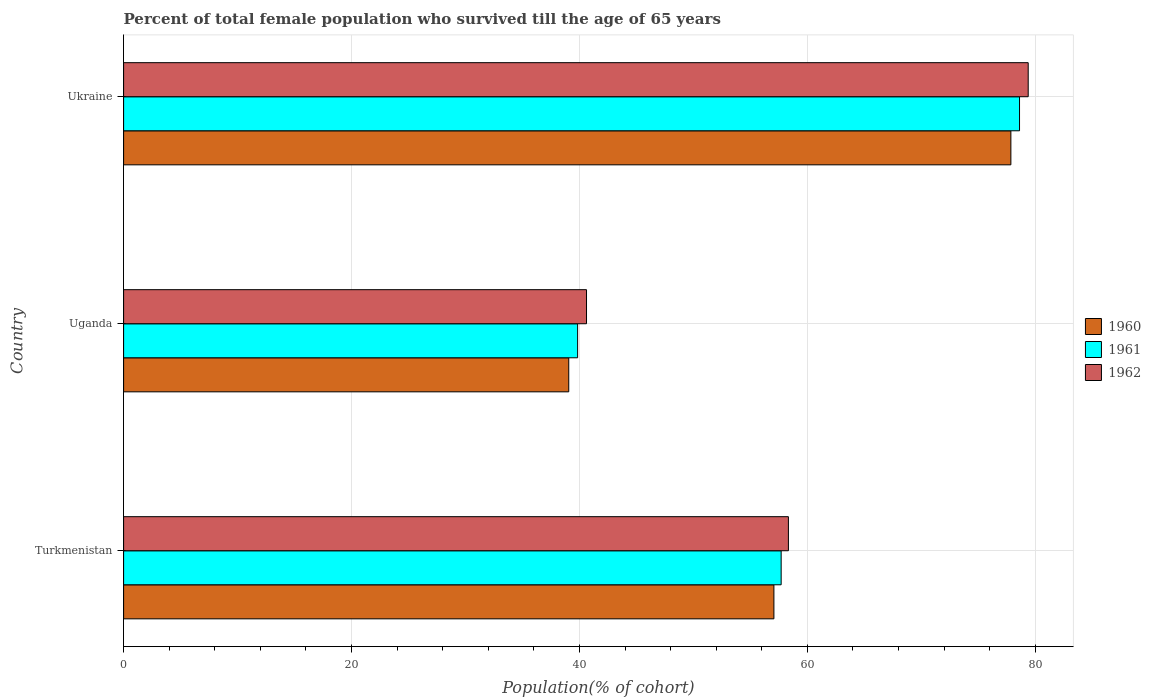How many different coloured bars are there?
Your answer should be compact. 3. What is the label of the 3rd group of bars from the top?
Ensure brevity in your answer.  Turkmenistan. In how many cases, is the number of bars for a given country not equal to the number of legend labels?
Provide a succinct answer. 0. What is the percentage of total female population who survived till the age of 65 years in 1962 in Turkmenistan?
Give a very brief answer. 58.33. Across all countries, what is the maximum percentage of total female population who survived till the age of 65 years in 1962?
Ensure brevity in your answer.  79.37. Across all countries, what is the minimum percentage of total female population who survived till the age of 65 years in 1962?
Keep it short and to the point. 40.62. In which country was the percentage of total female population who survived till the age of 65 years in 1960 maximum?
Your answer should be very brief. Ukraine. In which country was the percentage of total female population who survived till the age of 65 years in 1961 minimum?
Give a very brief answer. Uganda. What is the total percentage of total female population who survived till the age of 65 years in 1961 in the graph?
Provide a succinct answer. 176.15. What is the difference between the percentage of total female population who survived till the age of 65 years in 1962 in Turkmenistan and that in Uganda?
Offer a very short reply. 17.71. What is the difference between the percentage of total female population who survived till the age of 65 years in 1962 in Uganda and the percentage of total female population who survived till the age of 65 years in 1960 in Turkmenistan?
Your answer should be very brief. -16.44. What is the average percentage of total female population who survived till the age of 65 years in 1961 per country?
Your response must be concise. 58.72. What is the difference between the percentage of total female population who survived till the age of 65 years in 1961 and percentage of total female population who survived till the age of 65 years in 1962 in Ukraine?
Your answer should be compact. -0.76. What is the ratio of the percentage of total female population who survived till the age of 65 years in 1961 in Uganda to that in Ukraine?
Give a very brief answer. 0.51. What is the difference between the highest and the second highest percentage of total female population who survived till the age of 65 years in 1960?
Provide a short and direct response. 20.79. What is the difference between the highest and the lowest percentage of total female population who survived till the age of 65 years in 1960?
Provide a short and direct response. 38.79. In how many countries, is the percentage of total female population who survived till the age of 65 years in 1961 greater than the average percentage of total female population who survived till the age of 65 years in 1961 taken over all countries?
Offer a very short reply. 1. Is the sum of the percentage of total female population who survived till the age of 65 years in 1961 in Turkmenistan and Uganda greater than the maximum percentage of total female population who survived till the age of 65 years in 1962 across all countries?
Keep it short and to the point. Yes. What does the 3rd bar from the bottom in Ukraine represents?
Your response must be concise. 1962. Is it the case that in every country, the sum of the percentage of total female population who survived till the age of 65 years in 1960 and percentage of total female population who survived till the age of 65 years in 1962 is greater than the percentage of total female population who survived till the age of 65 years in 1961?
Your response must be concise. Yes. How many countries are there in the graph?
Your answer should be compact. 3. What is the difference between two consecutive major ticks on the X-axis?
Ensure brevity in your answer.  20. Does the graph contain any zero values?
Offer a very short reply. No. Does the graph contain grids?
Offer a very short reply. Yes. What is the title of the graph?
Your answer should be compact. Percent of total female population who survived till the age of 65 years. Does "1983" appear as one of the legend labels in the graph?
Keep it short and to the point. No. What is the label or title of the X-axis?
Offer a very short reply. Population(% of cohort). What is the Population(% of cohort) of 1960 in Turkmenistan?
Keep it short and to the point. 57.06. What is the Population(% of cohort) in 1961 in Turkmenistan?
Provide a succinct answer. 57.7. What is the Population(% of cohort) of 1962 in Turkmenistan?
Offer a terse response. 58.33. What is the Population(% of cohort) in 1960 in Uganda?
Make the answer very short. 39.06. What is the Population(% of cohort) of 1961 in Uganda?
Make the answer very short. 39.84. What is the Population(% of cohort) in 1962 in Uganda?
Make the answer very short. 40.62. What is the Population(% of cohort) in 1960 in Ukraine?
Your answer should be compact. 77.85. What is the Population(% of cohort) in 1961 in Ukraine?
Ensure brevity in your answer.  78.61. What is the Population(% of cohort) in 1962 in Ukraine?
Give a very brief answer. 79.37. Across all countries, what is the maximum Population(% of cohort) in 1960?
Keep it short and to the point. 77.85. Across all countries, what is the maximum Population(% of cohort) of 1961?
Make the answer very short. 78.61. Across all countries, what is the maximum Population(% of cohort) in 1962?
Give a very brief answer. 79.37. Across all countries, what is the minimum Population(% of cohort) in 1960?
Keep it short and to the point. 39.06. Across all countries, what is the minimum Population(% of cohort) in 1961?
Keep it short and to the point. 39.84. Across all countries, what is the minimum Population(% of cohort) in 1962?
Offer a terse response. 40.62. What is the total Population(% of cohort) in 1960 in the graph?
Your answer should be compact. 173.98. What is the total Population(% of cohort) in 1961 in the graph?
Keep it short and to the point. 176.15. What is the total Population(% of cohort) of 1962 in the graph?
Keep it short and to the point. 178.32. What is the difference between the Population(% of cohort) of 1960 in Turkmenistan and that in Uganda?
Offer a very short reply. 18. What is the difference between the Population(% of cohort) of 1961 in Turkmenistan and that in Uganda?
Your response must be concise. 17.86. What is the difference between the Population(% of cohort) in 1962 in Turkmenistan and that in Uganda?
Make the answer very short. 17.71. What is the difference between the Population(% of cohort) of 1960 in Turkmenistan and that in Ukraine?
Your response must be concise. -20.79. What is the difference between the Population(% of cohort) of 1961 in Turkmenistan and that in Ukraine?
Your response must be concise. -20.92. What is the difference between the Population(% of cohort) of 1962 in Turkmenistan and that in Ukraine?
Your response must be concise. -21.04. What is the difference between the Population(% of cohort) in 1960 in Uganda and that in Ukraine?
Offer a very short reply. -38.79. What is the difference between the Population(% of cohort) in 1961 in Uganda and that in Ukraine?
Your answer should be compact. -38.77. What is the difference between the Population(% of cohort) in 1962 in Uganda and that in Ukraine?
Make the answer very short. -38.76. What is the difference between the Population(% of cohort) in 1960 in Turkmenistan and the Population(% of cohort) in 1961 in Uganda?
Provide a short and direct response. 17.22. What is the difference between the Population(% of cohort) in 1960 in Turkmenistan and the Population(% of cohort) in 1962 in Uganda?
Provide a short and direct response. 16.44. What is the difference between the Population(% of cohort) of 1961 in Turkmenistan and the Population(% of cohort) of 1962 in Uganda?
Make the answer very short. 17.08. What is the difference between the Population(% of cohort) in 1960 in Turkmenistan and the Population(% of cohort) in 1961 in Ukraine?
Keep it short and to the point. -21.55. What is the difference between the Population(% of cohort) in 1960 in Turkmenistan and the Population(% of cohort) in 1962 in Ukraine?
Your answer should be compact. -22.31. What is the difference between the Population(% of cohort) of 1961 in Turkmenistan and the Population(% of cohort) of 1962 in Ukraine?
Your answer should be compact. -21.68. What is the difference between the Population(% of cohort) of 1960 in Uganda and the Population(% of cohort) of 1961 in Ukraine?
Ensure brevity in your answer.  -39.55. What is the difference between the Population(% of cohort) of 1960 in Uganda and the Population(% of cohort) of 1962 in Ukraine?
Give a very brief answer. -40.31. What is the difference between the Population(% of cohort) of 1961 in Uganda and the Population(% of cohort) of 1962 in Ukraine?
Make the answer very short. -39.53. What is the average Population(% of cohort) in 1960 per country?
Make the answer very short. 57.99. What is the average Population(% of cohort) in 1961 per country?
Keep it short and to the point. 58.72. What is the average Population(% of cohort) of 1962 per country?
Your response must be concise. 59.44. What is the difference between the Population(% of cohort) in 1960 and Population(% of cohort) in 1961 in Turkmenistan?
Give a very brief answer. -0.64. What is the difference between the Population(% of cohort) of 1960 and Population(% of cohort) of 1962 in Turkmenistan?
Ensure brevity in your answer.  -1.27. What is the difference between the Population(% of cohort) of 1961 and Population(% of cohort) of 1962 in Turkmenistan?
Make the answer very short. -0.64. What is the difference between the Population(% of cohort) of 1960 and Population(% of cohort) of 1961 in Uganda?
Your answer should be compact. -0.78. What is the difference between the Population(% of cohort) in 1960 and Population(% of cohort) in 1962 in Uganda?
Keep it short and to the point. -1.56. What is the difference between the Population(% of cohort) of 1961 and Population(% of cohort) of 1962 in Uganda?
Provide a succinct answer. -0.78. What is the difference between the Population(% of cohort) in 1960 and Population(% of cohort) in 1961 in Ukraine?
Offer a terse response. -0.76. What is the difference between the Population(% of cohort) in 1960 and Population(% of cohort) in 1962 in Ukraine?
Your answer should be compact. -1.52. What is the difference between the Population(% of cohort) of 1961 and Population(% of cohort) of 1962 in Ukraine?
Offer a very short reply. -0.76. What is the ratio of the Population(% of cohort) of 1960 in Turkmenistan to that in Uganda?
Offer a terse response. 1.46. What is the ratio of the Population(% of cohort) in 1961 in Turkmenistan to that in Uganda?
Your answer should be compact. 1.45. What is the ratio of the Population(% of cohort) in 1962 in Turkmenistan to that in Uganda?
Provide a succinct answer. 1.44. What is the ratio of the Population(% of cohort) of 1960 in Turkmenistan to that in Ukraine?
Your answer should be compact. 0.73. What is the ratio of the Population(% of cohort) in 1961 in Turkmenistan to that in Ukraine?
Provide a succinct answer. 0.73. What is the ratio of the Population(% of cohort) in 1962 in Turkmenistan to that in Ukraine?
Make the answer very short. 0.73. What is the ratio of the Population(% of cohort) of 1960 in Uganda to that in Ukraine?
Keep it short and to the point. 0.5. What is the ratio of the Population(% of cohort) of 1961 in Uganda to that in Ukraine?
Ensure brevity in your answer.  0.51. What is the ratio of the Population(% of cohort) of 1962 in Uganda to that in Ukraine?
Give a very brief answer. 0.51. What is the difference between the highest and the second highest Population(% of cohort) in 1960?
Offer a terse response. 20.79. What is the difference between the highest and the second highest Population(% of cohort) of 1961?
Your answer should be compact. 20.92. What is the difference between the highest and the second highest Population(% of cohort) of 1962?
Your response must be concise. 21.04. What is the difference between the highest and the lowest Population(% of cohort) of 1960?
Make the answer very short. 38.79. What is the difference between the highest and the lowest Population(% of cohort) of 1961?
Your response must be concise. 38.77. What is the difference between the highest and the lowest Population(% of cohort) of 1962?
Ensure brevity in your answer.  38.76. 